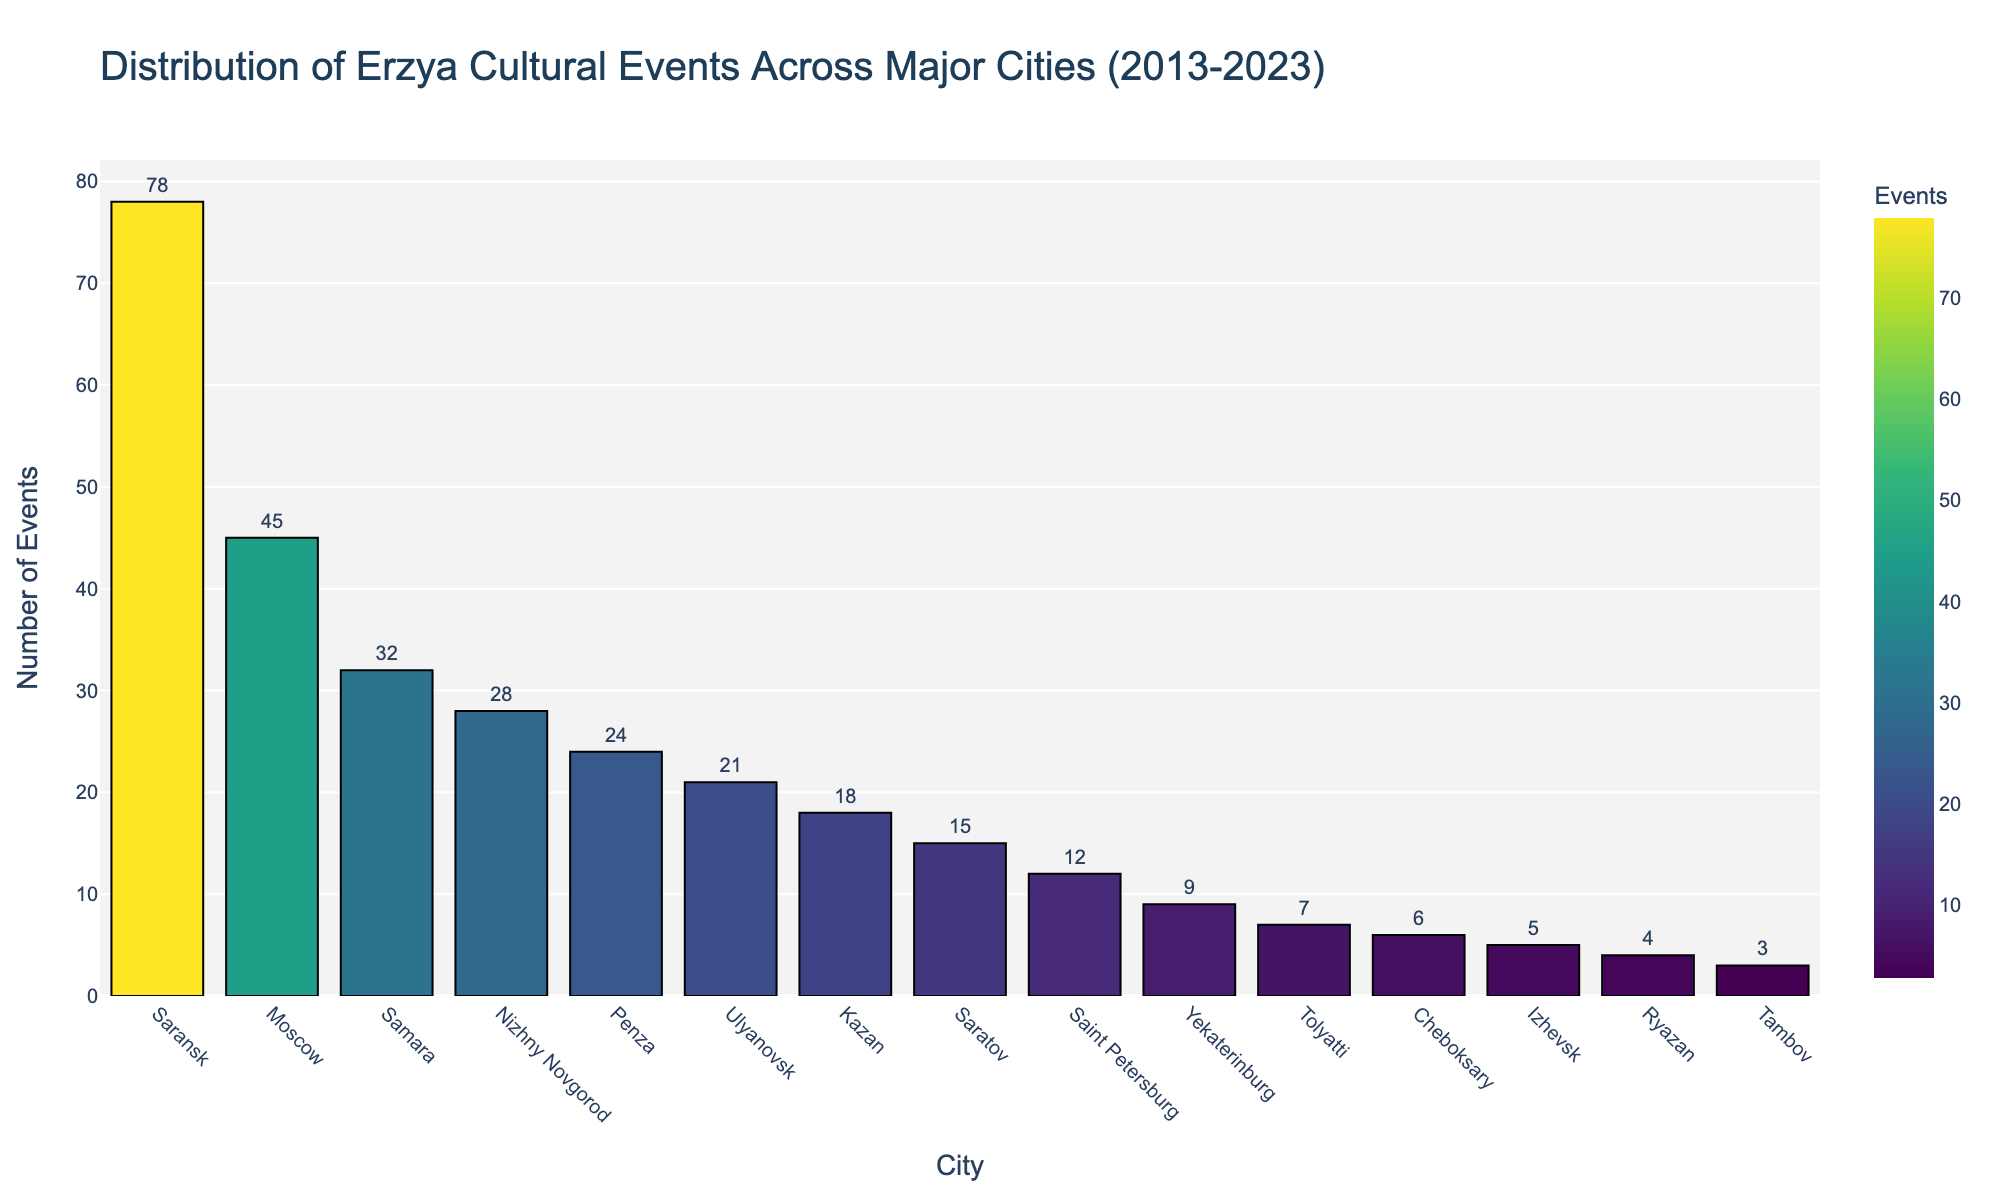Which city hosted the highest number of Erzya cultural events? Saransk hosted the highest number of Erzya cultural events with 78 events.
Answer: Saransk How many Erzya cultural events were held in Moscow? The bar representing Moscow shows that 45 Erzya cultural events were held there.
Answer: 45 Which city has the lowest number of Erzya cultural events? Tambov has the lowest number of Erzya cultural events, with just 3 events.
Answer: Tambov What is the total number of Erzya cultural events held across all cities? Sum the number of events in each city: 78 + 45 + 32 + 28 + 24 + 21 + 18 + 15 + 12 + 9 + 7 + 6 + 5 + 4 + 3 = 307.
Answer: 307 Compare the number of Erzya cultural events in Kazan and Saratov. Which city had more events? Kazan had 18 events, and Saratov had 15 events. Kazan had more Erzya cultural events.
Answer: Kazan How much more Erzya cultural events were held in Saransk compared to Saint-Petersburg? Subtract the number of events in Saint-Petersburg from the number of events in Saransk: 78 - 12 = 66.
Answer: 66 What is the average number of Erzya cultural events per city? Divide the total number of events by the number of cities: 307 events / 15 cities = 20.47 events per city (rounded to 2 decimal places).
Answer: 20.47 Identify the cities that hosted fewer than 10 Erzya cultural events. The cities with fewer than 10 events are Yekaterinburg (9), Tolyatti (7), Cheboksary (6), Izhevsk (5), Ryazan (4), and Tambov (3).
Answer: Yekaterinburg, Tolyatti, Cheboksary, Izhevsk, Ryazan, Tambov What is the difference between the highest and lowest number of Erzya cultural events held in the cities? Subtract the number of events in the city with the lowest number from the city with the highest number: 78 (Saransk) - 3 (Tambov) = 75.
Answer: 75 List the top three cities by the number of Erzya cultural events held. The top three cities by the number of events are Saransk (78), Moscow (45), and Samara (32).
Answer: Saransk, Moscow, Samara 